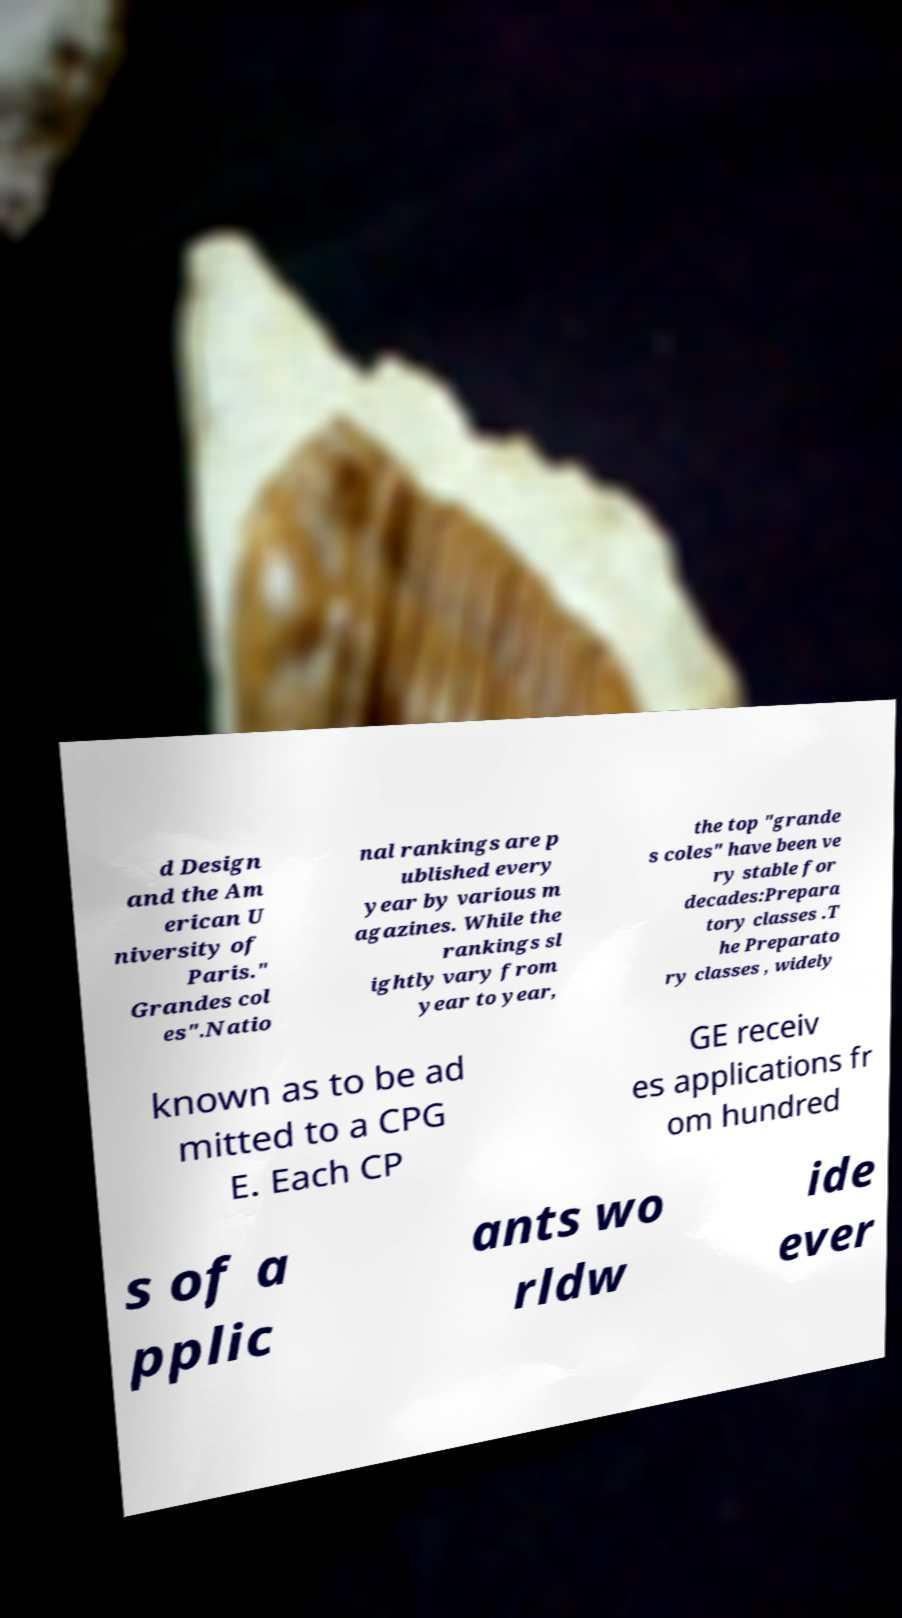For documentation purposes, I need the text within this image transcribed. Could you provide that? d Design and the Am erican U niversity of Paris." Grandes col es".Natio nal rankings are p ublished every year by various m agazines. While the rankings sl ightly vary from year to year, the top "grande s coles" have been ve ry stable for decades:Prepara tory classes .T he Preparato ry classes , widely known as to be ad mitted to a CPG E. Each CP GE receiv es applications fr om hundred s of a pplic ants wo rldw ide ever 